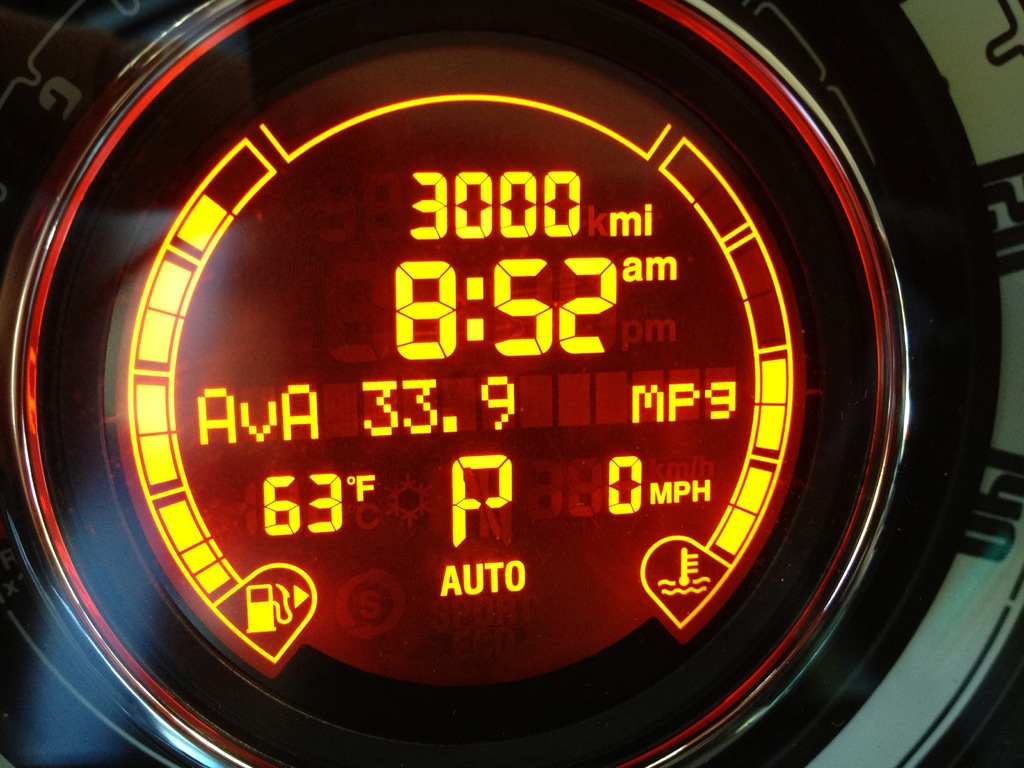What's happening in the scene? The dashboard displays key information about the car's status. It indicates 3000 miles have been driven, shown within a circular screen lit with red and orange hues. The time is currently 8:52 AM. The screen also shows that the car is stationary with a speed of 0 MPH and is in automatic mode, as highlighted by the 'AUTO' sign. The average fuel efficiency is 33.9 MPG, and the external temperature is a mild 67 degrees Fahrenheit. 